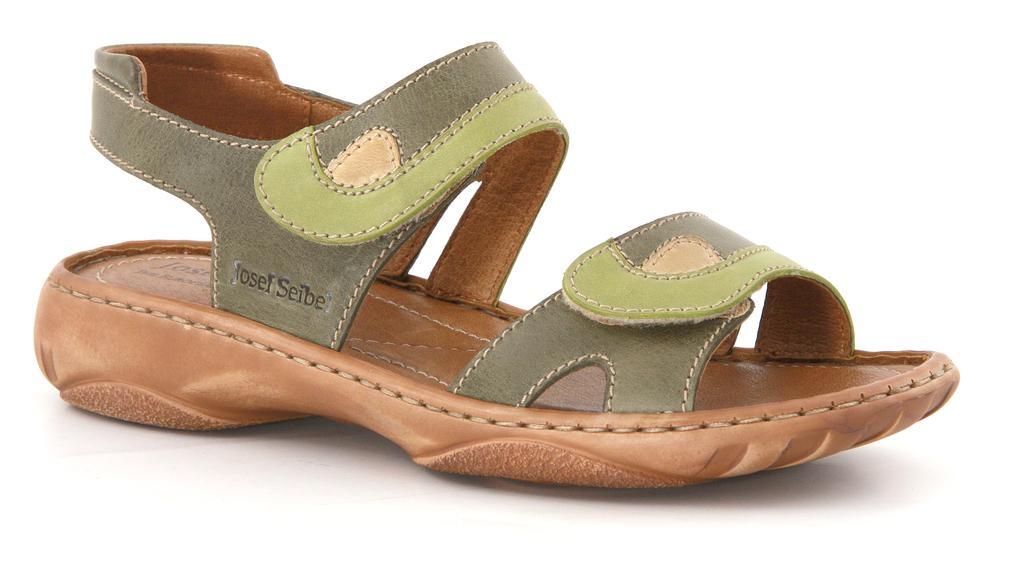Can you describe this image briefly? In this picture we can see a footwear. Background is white in color. 